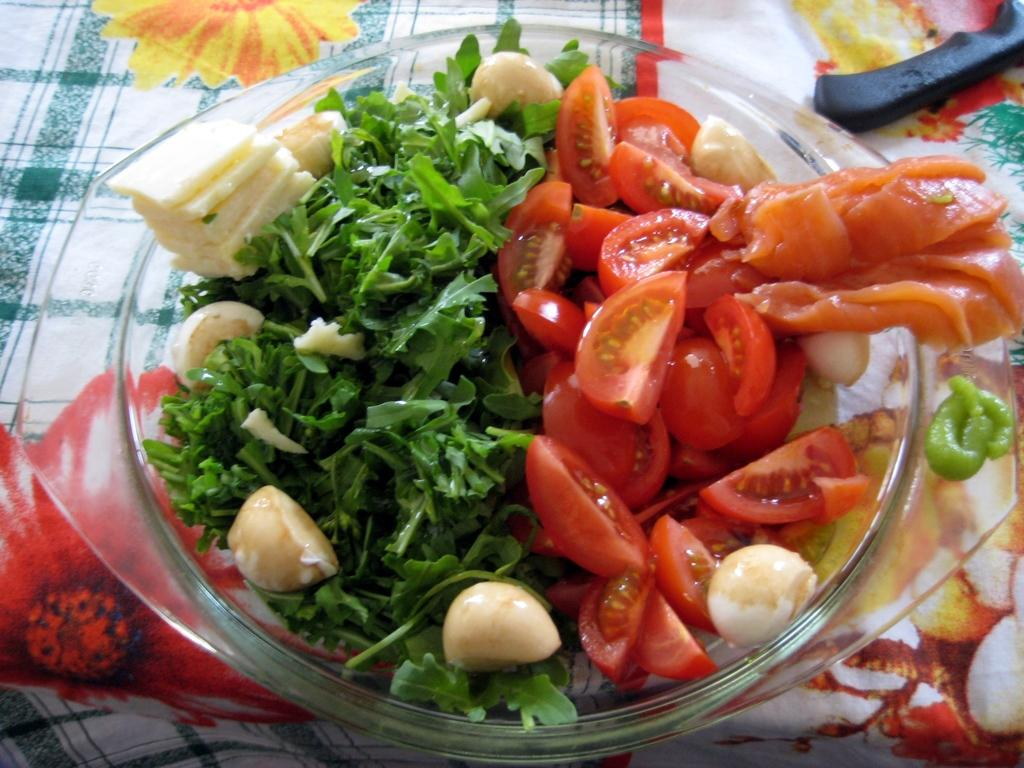What type of objects can be seen in the image? There are food items in the image. How are the food items contained or displayed? The food items are in a glass bowl. What is the chance of the food items being gripped by a rifle in the image? There is no rifle present in the image, so the chance of the food items being gripped by a rifle is zero. 